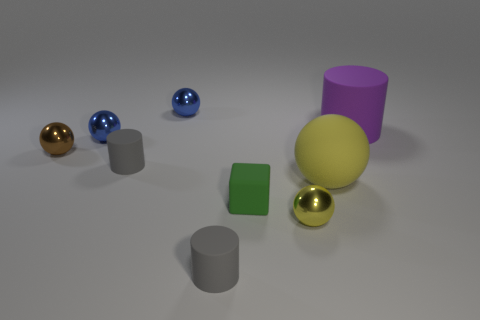How many small objects are both behind the tiny yellow thing and in front of the rubber ball?
Ensure brevity in your answer.  1. There is a gray matte cylinder that is behind the large ball; is it the same size as the blue object that is in front of the big purple matte object?
Make the answer very short. Yes. How big is the gray thing that is in front of the small block?
Make the answer very short. Small. How many things are either rubber cylinders that are right of the tiny rubber cube or cylinders in front of the small yellow sphere?
Your response must be concise. 2. Are there any other things of the same color as the big matte cylinder?
Make the answer very short. No. Are there the same number of metal spheres left of the tiny yellow metallic object and small yellow metal things right of the big yellow ball?
Your answer should be compact. No. Are there more yellow shiny balls to the left of the big yellow thing than small blue metallic things?
Your answer should be very brief. No. How many things are purple matte things behind the green block or gray shiny balls?
Keep it short and to the point. 1. How many large purple cylinders have the same material as the small yellow thing?
Give a very brief answer. 0. There is a tiny object that is the same color as the big rubber ball; what is its shape?
Provide a succinct answer. Sphere. 